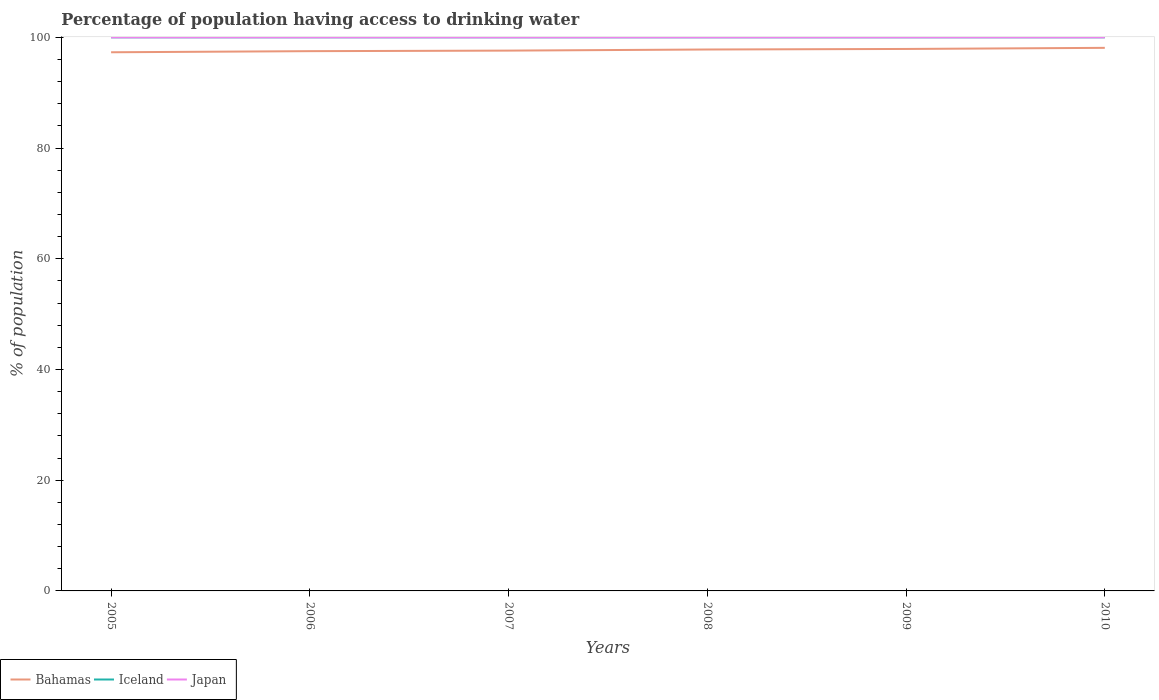Across all years, what is the maximum percentage of population having access to drinking water in Japan?
Offer a terse response. 100. In which year was the percentage of population having access to drinking water in Japan maximum?
Give a very brief answer. 2005. What is the total percentage of population having access to drinking water in Japan in the graph?
Your answer should be compact. 0. What is the difference between the highest and the second highest percentage of population having access to drinking water in Bahamas?
Offer a terse response. 0.8. What is the difference between the highest and the lowest percentage of population having access to drinking water in Japan?
Your answer should be compact. 0. How many lines are there?
Keep it short and to the point. 3. What is the difference between two consecutive major ticks on the Y-axis?
Provide a succinct answer. 20. What is the title of the graph?
Provide a short and direct response. Percentage of population having access to drinking water. What is the label or title of the Y-axis?
Offer a very short reply. % of population. What is the % of population of Bahamas in 2005?
Provide a succinct answer. 97.3. What is the % of population in Iceland in 2005?
Your answer should be compact. 100. What is the % of population of Bahamas in 2006?
Ensure brevity in your answer.  97.5. What is the % of population of Japan in 2006?
Give a very brief answer. 100. What is the % of population of Bahamas in 2007?
Provide a succinct answer. 97.6. What is the % of population in Bahamas in 2008?
Your response must be concise. 97.8. What is the % of population in Iceland in 2008?
Offer a very short reply. 100. What is the % of population in Japan in 2008?
Offer a terse response. 100. What is the % of population of Bahamas in 2009?
Your answer should be compact. 97.9. What is the % of population in Iceland in 2009?
Offer a very short reply. 100. What is the % of population in Japan in 2009?
Your answer should be very brief. 100. What is the % of population of Bahamas in 2010?
Your response must be concise. 98.1. What is the % of population in Iceland in 2010?
Your answer should be very brief. 100. Across all years, what is the maximum % of population of Bahamas?
Keep it short and to the point. 98.1. Across all years, what is the maximum % of population in Iceland?
Provide a short and direct response. 100. Across all years, what is the minimum % of population of Bahamas?
Ensure brevity in your answer.  97.3. Across all years, what is the minimum % of population of Iceland?
Offer a terse response. 100. What is the total % of population in Bahamas in the graph?
Your answer should be very brief. 586.2. What is the total % of population of Iceland in the graph?
Ensure brevity in your answer.  600. What is the total % of population of Japan in the graph?
Your answer should be very brief. 600. What is the difference between the % of population of Bahamas in 2005 and that in 2006?
Offer a terse response. -0.2. What is the difference between the % of population of Japan in 2005 and that in 2006?
Give a very brief answer. 0. What is the difference between the % of population in Bahamas in 2005 and that in 2007?
Your answer should be compact. -0.3. What is the difference between the % of population of Iceland in 2005 and that in 2007?
Give a very brief answer. 0. What is the difference between the % of population of Bahamas in 2005 and that in 2008?
Offer a terse response. -0.5. What is the difference between the % of population of Iceland in 2005 and that in 2008?
Offer a very short reply. 0. What is the difference between the % of population of Japan in 2005 and that in 2008?
Provide a succinct answer. 0. What is the difference between the % of population of Iceland in 2005 and that in 2009?
Give a very brief answer. 0. What is the difference between the % of population of Bahamas in 2005 and that in 2010?
Your answer should be very brief. -0.8. What is the difference between the % of population of Iceland in 2005 and that in 2010?
Your answer should be very brief. 0. What is the difference between the % of population in Japan in 2005 and that in 2010?
Make the answer very short. 0. What is the difference between the % of population in Iceland in 2006 and that in 2007?
Keep it short and to the point. 0. What is the difference between the % of population of Japan in 2006 and that in 2007?
Keep it short and to the point. 0. What is the difference between the % of population in Bahamas in 2006 and that in 2008?
Your answer should be very brief. -0.3. What is the difference between the % of population in Iceland in 2006 and that in 2008?
Give a very brief answer. 0. What is the difference between the % of population in Japan in 2006 and that in 2009?
Make the answer very short. 0. What is the difference between the % of population in Bahamas in 2007 and that in 2009?
Offer a terse response. -0.3. What is the difference between the % of population of Iceland in 2007 and that in 2009?
Ensure brevity in your answer.  0. What is the difference between the % of population of Japan in 2007 and that in 2010?
Ensure brevity in your answer.  0. What is the difference between the % of population in Iceland in 2008 and that in 2009?
Your response must be concise. 0. What is the difference between the % of population in Iceland in 2009 and that in 2010?
Give a very brief answer. 0. What is the difference between the % of population in Bahamas in 2005 and the % of population in Japan in 2006?
Offer a very short reply. -2.7. What is the difference between the % of population in Iceland in 2005 and the % of population in Japan in 2006?
Offer a terse response. 0. What is the difference between the % of population in Bahamas in 2005 and the % of population in Iceland in 2007?
Provide a short and direct response. -2.7. What is the difference between the % of population in Bahamas in 2005 and the % of population in Japan in 2007?
Provide a succinct answer. -2.7. What is the difference between the % of population in Bahamas in 2005 and the % of population in Iceland in 2008?
Offer a terse response. -2.7. What is the difference between the % of population of Iceland in 2005 and the % of population of Japan in 2009?
Your response must be concise. 0. What is the difference between the % of population in Iceland in 2005 and the % of population in Japan in 2010?
Offer a terse response. 0. What is the difference between the % of population in Bahamas in 2006 and the % of population in Japan in 2007?
Provide a succinct answer. -2.5. What is the difference between the % of population of Bahamas in 2006 and the % of population of Japan in 2008?
Your answer should be very brief. -2.5. What is the difference between the % of population of Iceland in 2006 and the % of population of Japan in 2008?
Make the answer very short. 0. What is the difference between the % of population in Bahamas in 2006 and the % of population in Iceland in 2009?
Your answer should be compact. -2.5. What is the difference between the % of population of Iceland in 2006 and the % of population of Japan in 2010?
Your answer should be compact. 0. What is the difference between the % of population in Bahamas in 2007 and the % of population in Iceland in 2008?
Make the answer very short. -2.4. What is the difference between the % of population of Iceland in 2007 and the % of population of Japan in 2008?
Your answer should be very brief. 0. What is the difference between the % of population in Bahamas in 2007 and the % of population in Iceland in 2009?
Your answer should be very brief. -2.4. What is the difference between the % of population of Bahamas in 2007 and the % of population of Iceland in 2010?
Provide a succinct answer. -2.4. What is the difference between the % of population of Iceland in 2007 and the % of population of Japan in 2010?
Give a very brief answer. 0. What is the difference between the % of population of Bahamas in 2008 and the % of population of Iceland in 2010?
Keep it short and to the point. -2.2. What is the difference between the % of population of Bahamas in 2009 and the % of population of Iceland in 2010?
Provide a succinct answer. -2.1. What is the difference between the % of population of Bahamas in 2009 and the % of population of Japan in 2010?
Offer a terse response. -2.1. What is the difference between the % of population of Iceland in 2009 and the % of population of Japan in 2010?
Your answer should be compact. 0. What is the average % of population of Bahamas per year?
Make the answer very short. 97.7. In the year 2005, what is the difference between the % of population of Bahamas and % of population of Iceland?
Your answer should be compact. -2.7. In the year 2005, what is the difference between the % of population of Iceland and % of population of Japan?
Your answer should be compact. 0. In the year 2006, what is the difference between the % of population of Bahamas and % of population of Japan?
Keep it short and to the point. -2.5. In the year 2006, what is the difference between the % of population of Iceland and % of population of Japan?
Offer a very short reply. 0. In the year 2008, what is the difference between the % of population in Bahamas and % of population in Japan?
Ensure brevity in your answer.  -2.2. In the year 2009, what is the difference between the % of population of Iceland and % of population of Japan?
Offer a very short reply. 0. In the year 2010, what is the difference between the % of population in Bahamas and % of population in Iceland?
Offer a very short reply. -1.9. In the year 2010, what is the difference between the % of population of Bahamas and % of population of Japan?
Make the answer very short. -1.9. In the year 2010, what is the difference between the % of population of Iceland and % of population of Japan?
Keep it short and to the point. 0. What is the ratio of the % of population in Bahamas in 2005 to that in 2006?
Give a very brief answer. 1. What is the ratio of the % of population of Iceland in 2005 to that in 2006?
Ensure brevity in your answer.  1. What is the ratio of the % of population in Bahamas in 2005 to that in 2008?
Provide a succinct answer. 0.99. What is the ratio of the % of population of Iceland in 2005 to that in 2008?
Keep it short and to the point. 1. What is the ratio of the % of population of Japan in 2005 to that in 2008?
Your answer should be compact. 1. What is the ratio of the % of population in Bahamas in 2005 to that in 2010?
Your response must be concise. 0.99. What is the ratio of the % of population of Iceland in 2005 to that in 2010?
Your answer should be compact. 1. What is the ratio of the % of population in Iceland in 2006 to that in 2007?
Provide a succinct answer. 1. What is the ratio of the % of population in Bahamas in 2006 to that in 2008?
Provide a succinct answer. 1. What is the ratio of the % of population in Iceland in 2006 to that in 2008?
Provide a short and direct response. 1. What is the ratio of the % of population in Japan in 2006 to that in 2008?
Provide a succinct answer. 1. What is the ratio of the % of population in Bahamas in 2006 to that in 2010?
Give a very brief answer. 0.99. What is the ratio of the % of population in Iceland in 2007 to that in 2008?
Ensure brevity in your answer.  1. What is the ratio of the % of population of Iceland in 2007 to that in 2009?
Your answer should be compact. 1. What is the ratio of the % of population in Japan in 2007 to that in 2009?
Give a very brief answer. 1. What is the ratio of the % of population in Iceland in 2007 to that in 2010?
Your answer should be compact. 1. What is the ratio of the % of population of Japan in 2007 to that in 2010?
Your answer should be compact. 1. What is the ratio of the % of population in Iceland in 2008 to that in 2009?
Provide a succinct answer. 1. What is the ratio of the % of population of Bahamas in 2008 to that in 2010?
Offer a terse response. 1. What is the ratio of the % of population of Iceland in 2008 to that in 2010?
Provide a short and direct response. 1. What is the ratio of the % of population in Japan in 2009 to that in 2010?
Make the answer very short. 1. What is the difference between the highest and the second highest % of population of Bahamas?
Your response must be concise. 0.2. What is the difference between the highest and the second highest % of population in Japan?
Give a very brief answer. 0. What is the difference between the highest and the lowest % of population in Iceland?
Provide a short and direct response. 0. 